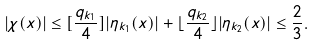Convert formula to latex. <formula><loc_0><loc_0><loc_500><loc_500>| \chi ( x ) | \leq [ \frac { q _ { k _ { 1 } } } { 4 } ] | \eta _ { k _ { 1 } } ( x ) | + \lfloor \frac { q _ { k _ { 2 } } } { 4 } \rfloor | \eta _ { k _ { 2 } } ( x ) | \leq \frac { 2 } { 3 } .</formula> 